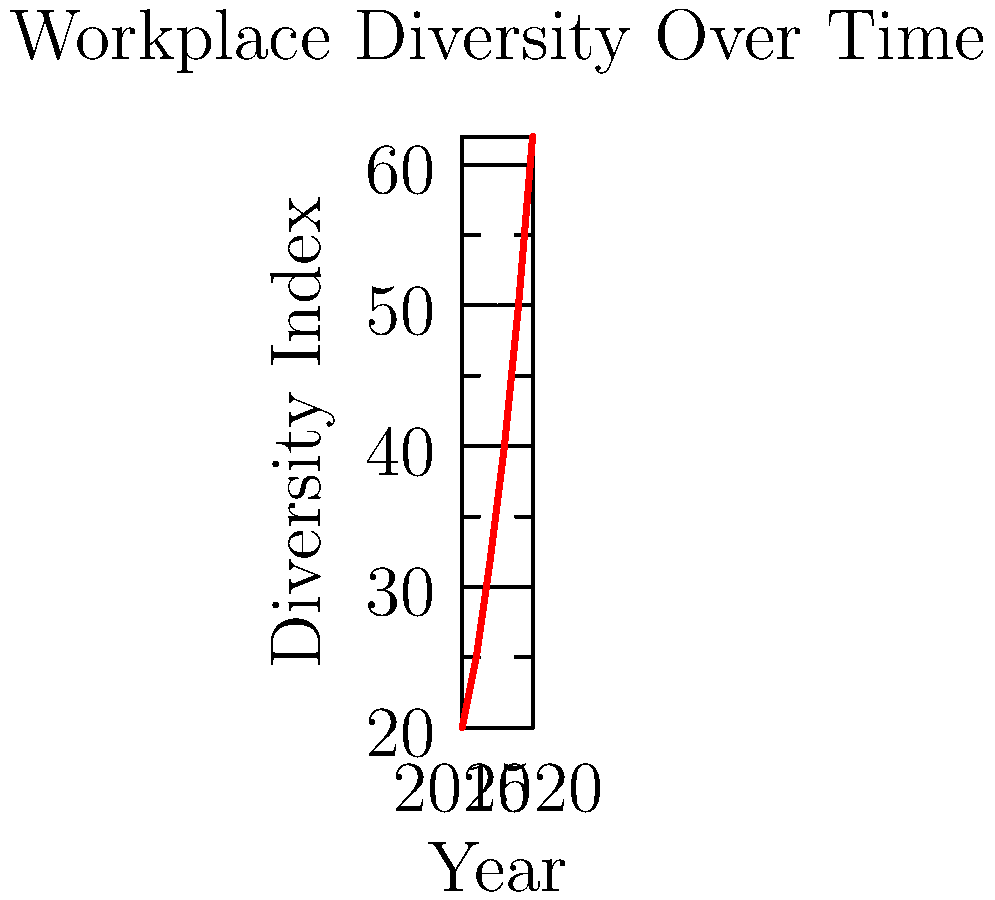Based on the line graph showing the increase in workplace diversity from 2015 to 2020, what is the average annual increase in the diversity index? To calculate the average annual increase in the diversity index:

1. Calculate the total increase:
   Final value (2020) - Initial value (2015) = 62 - 20 = 42

2. Determine the number of years:
   2020 - 2015 = 5 years

3. Calculate the average annual increase:
   Total increase ÷ Number of years = 42 ÷ 5 = 8.4

Therefore, the average annual increase in the diversity index is 8.4 points per year.

This can be represented mathematically as:

$$ \text{Average Annual Increase} = \frac{\text{Final Value} - \text{Initial Value}}{\text{Number of Years}} = \frac{62 - 20}{5} = 8.4 $$
Answer: 8.4 points per year 